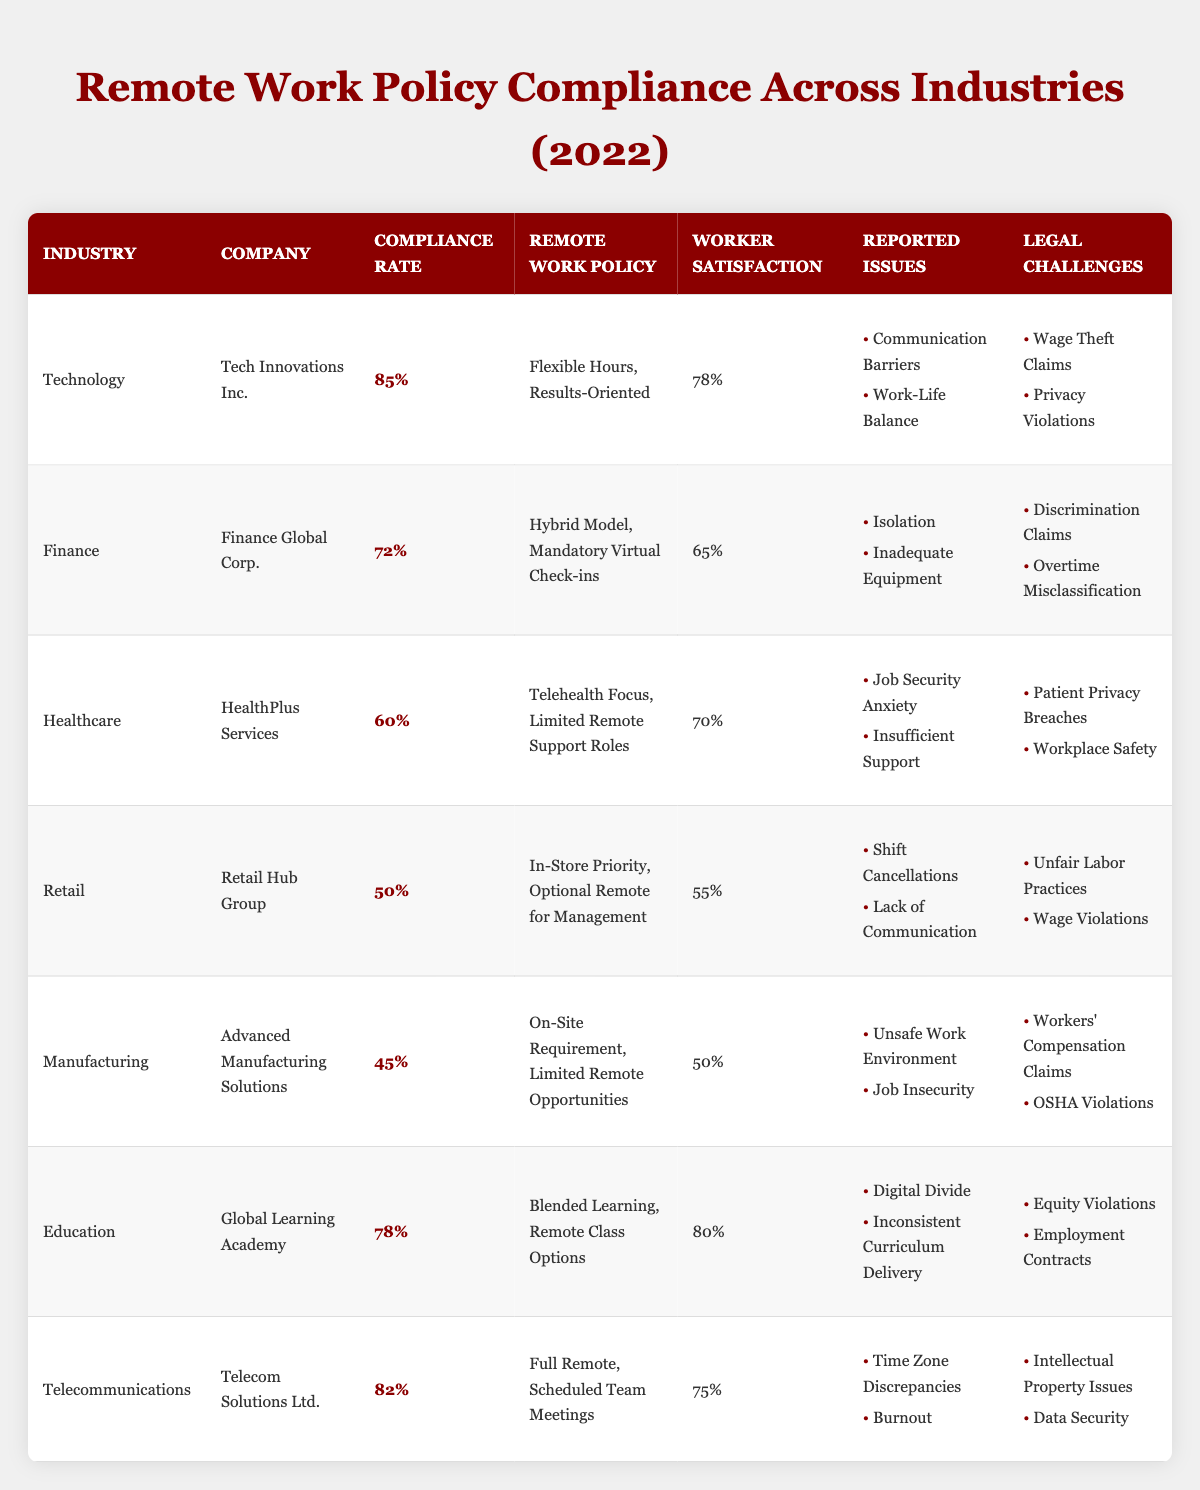What is the compliance rate of the Healthcare industry? The table shows that the compliance rate for the Healthcare industry is listed as 60%.
Answer: 60% Which company in the Manufacturing industry has the lowest compliance rate? According to the table, Advanced Manufacturing Solutions has the lowest compliance rate at 45%.
Answer: Advanced Manufacturing Solutions How many industries have a compliance rate above 70%? The table indicates that Technology (85%), Telecommunications (82%), and Education (78%) are the only industries above 70%, which totals to three industries.
Answer: 3 What is the reported issue with the highest worker satisfaction in the Education industry? The worker satisfaction in the Education industry is 80%, and the reported issues mentioned are "Digital Divide" and "Inconsistent Curriculum Delivery"—the highest satisfaction does not directly correlate but indicates fewer issues are reported comparatively.
Answer: No specific reported issue; overall satisfaction is 80% Is the average compliance rate for Finance and Healthcare industries greater than 65%? The compliance rates for Finance (72%) and Healthcare (60%) combine to give (72 + 60) = 132, and the average is 132 / 2 = 66%, which is greater than 65%.
Answer: Yes What remote work policy is implemented by Finance Global Corp.? The table specifies that Finance Global Corp. has a remote work policy of "Hybrid Model, Mandatory Virtual Check-ins."
Answer: Hybrid Model, Mandatory Virtual Check-ins Do all companies in the Retail and Manufacturing industries report the same legal challenges? The Retail industry mentions "Unfair Labor Practices" and "Wage Violations" while Manufacturing lists "Workers' Compensation Claims" and "OSHA Violations." Since these challenges differ, the answer is no.
Answer: No Which industry has the highest reported issues, and what are they? While no direct count of issues is provided, the Retail and Manufacturing industries both have two issues for the legal challenges listed in the table, alongside others, not ranking them individually. The documented issues in Retail include "Shift Cancellations" and "Lack of Communication".
Answer: Retail industry; issues are Shift Cancellations and Lack of Communication What is the total number of reported issues across all companies listed? Counting the issues: Technology (2), Finance (2), Healthcare (2), Retail (2), Manufacturing (2), Education (2), Telecommunications (2) gives a total of 14 reported issues.
Answer: 14 Is there a correlation between compliance rate and worker satisfaction in the Technology industry? Technology displays a compliance rate of 85% and worker satisfaction of 78%. A high compliance rate often reflects better worker satisfaction, indicating a reasonable positive correlation exists without direct metrics to measure it.
Answer: Yes, there is a correlation 